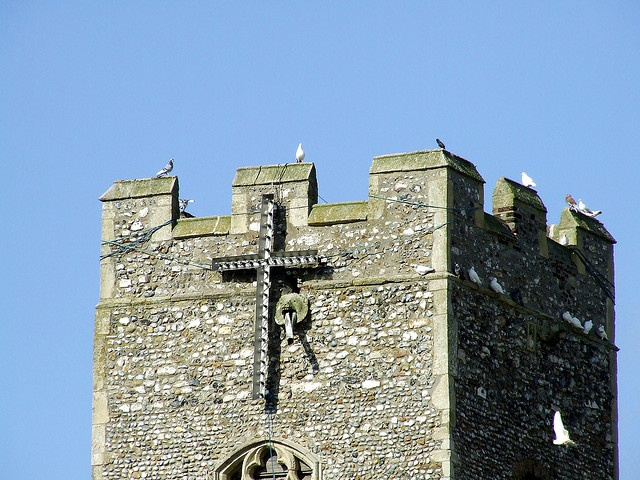Describe the objects in this image and their specific colors. I can see bird in lightblue, black, gray, and white tones, bird in lightblue, white, gray, black, and beige tones, bird in lightblue, white, darkgray, gray, and beige tones, bird in lightblue, white, gray, darkgray, and lavender tones, and bird in lightblue, gray, black, and darkgray tones in this image. 